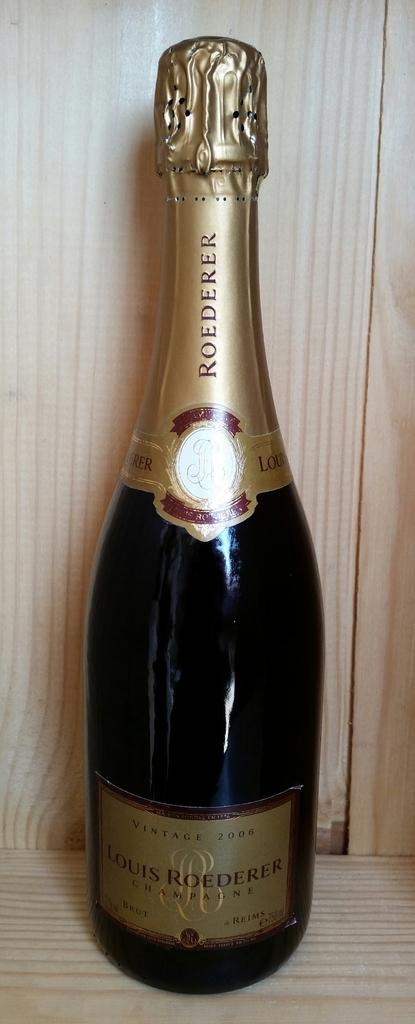What year is this?
Your answer should be compact. 2006. 